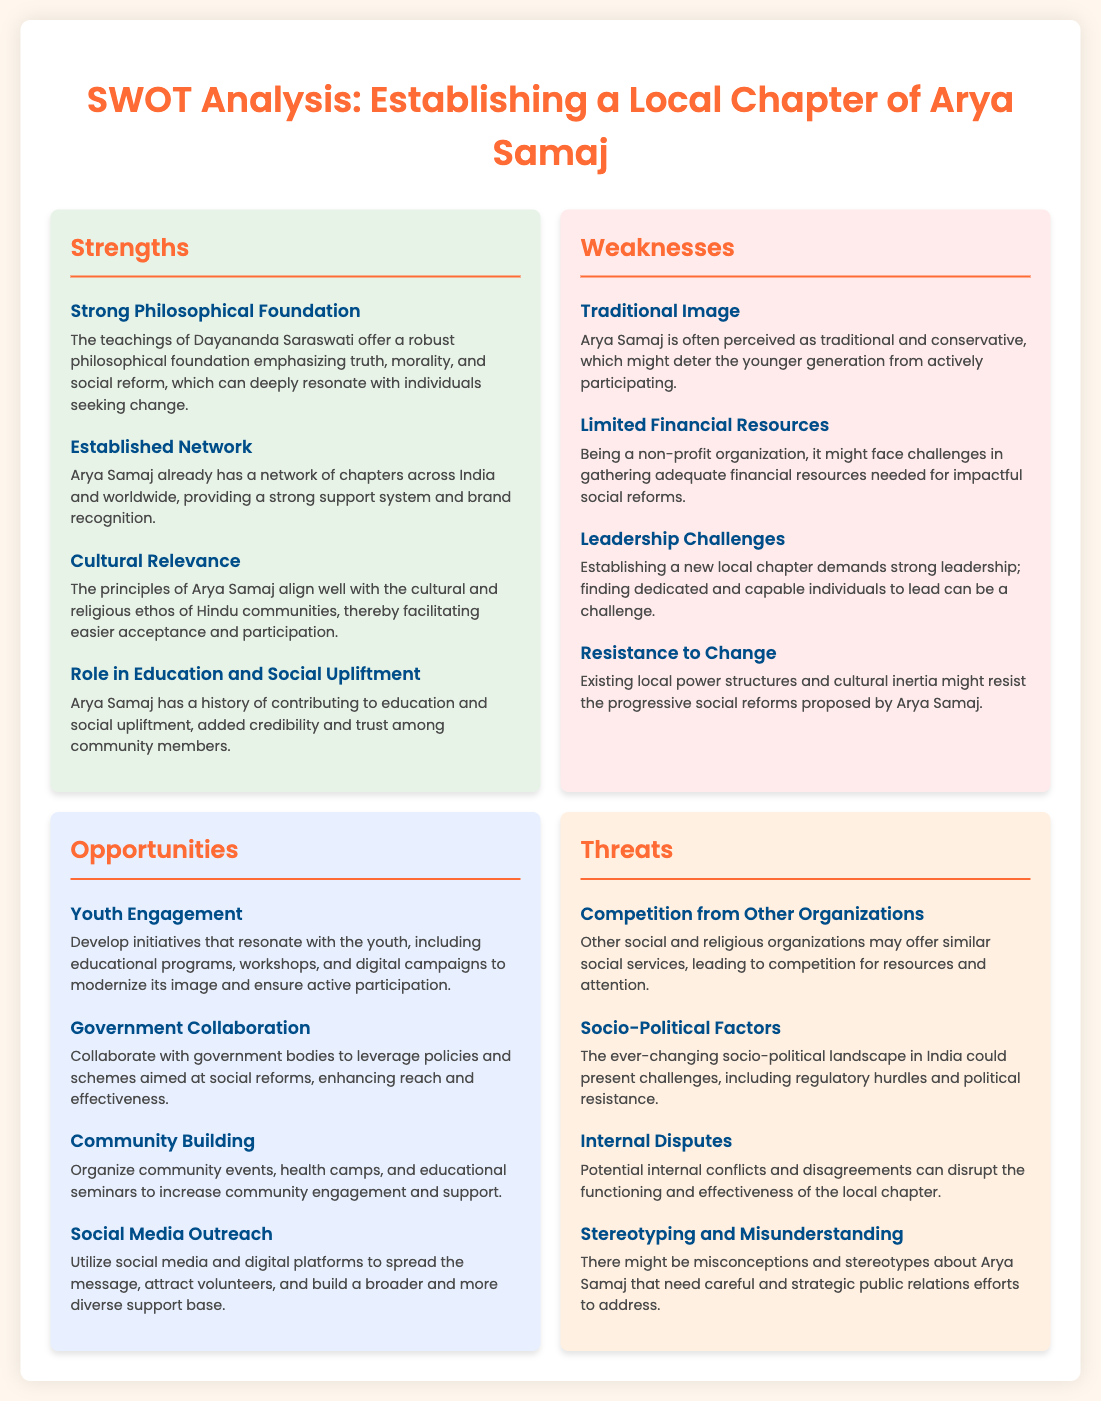What is a key strength of establishing an Arya Samaj local chapter? The document mentions a strong philosophical foundation emphasizing truth, morality, and social reform as a key strength.
Answer: Strong Philosophical Foundation What is a major weakness identified in the SWOT analysis? The analysis points out a traditional image as a major weakness that might deter the younger generation.
Answer: Traditional Image How many opportunities are listed in the document? The document lists four opportunities for establishing the local chapter of Arya Samaj.
Answer: Four What is one opportunity for community engagement? The document specifies organizing community events as an opportunity for increased community engagement and support.
Answer: Community events What threat is related to competition? The document states that competition from other organizations may lead to competition for resources and attention as a threat.
Answer: Competition from Other Organizations What role do socio-political factors play according to the analysis? The document indicates that socio-political factors could present challenges, signaling their impact on the establishment of the local chapter.
Answer: Socio-Political Factors What action is suggested to modernize the image of Arya Samaj? The document suggests developing initiatives that resonate with the youth to modernize its image.
Answer: Youth Engagement What can be a consequence of internal disputes? According to the document, internal disputes can disrupt the functioning and effectiveness of the local chapter.
Answer: Internal Disputes 